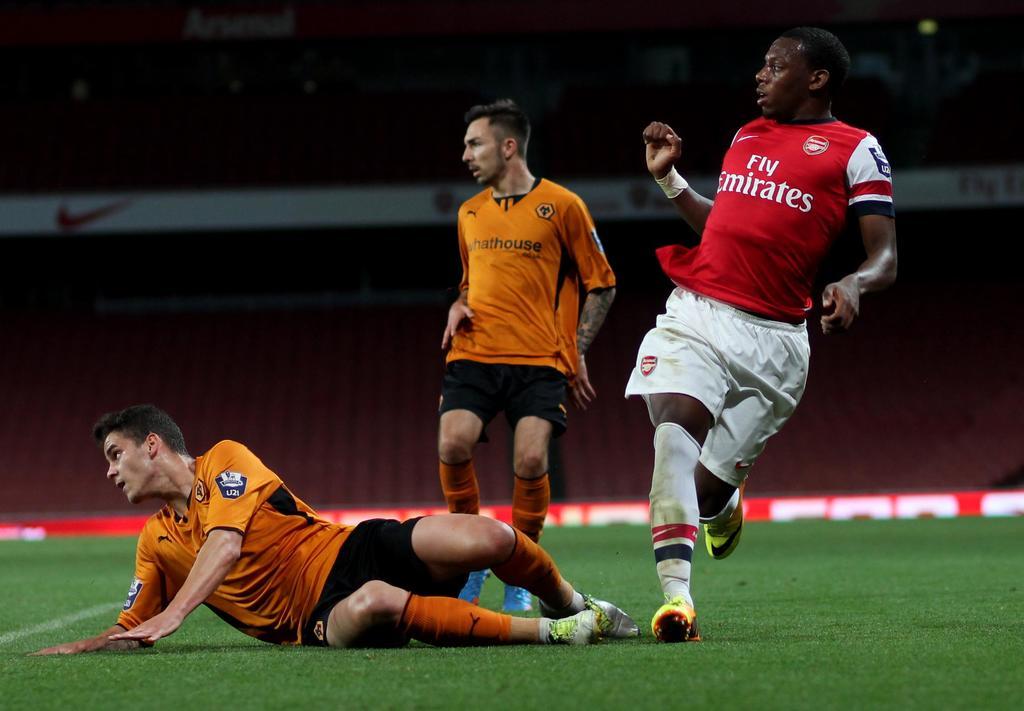What team does the guy in the red shirt play for?
Give a very brief answer. Emirates. 